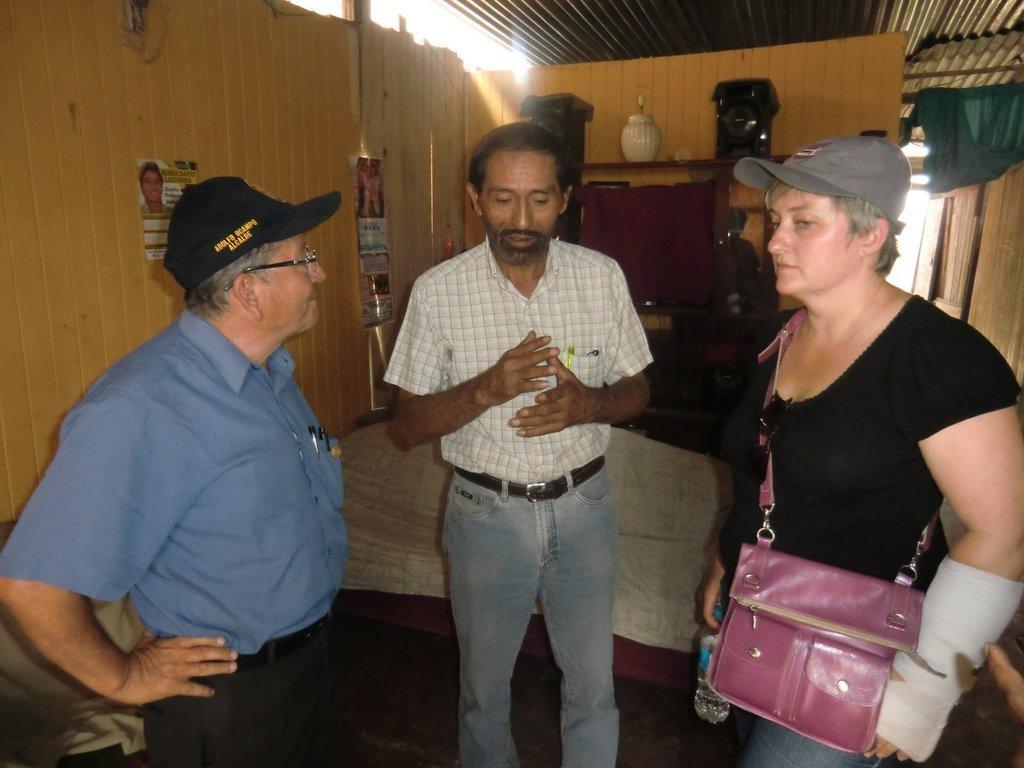How would you summarize this image in a sentence or two? In the image we can see there are people who are standing and a woman is wearing a pink colour purse. 